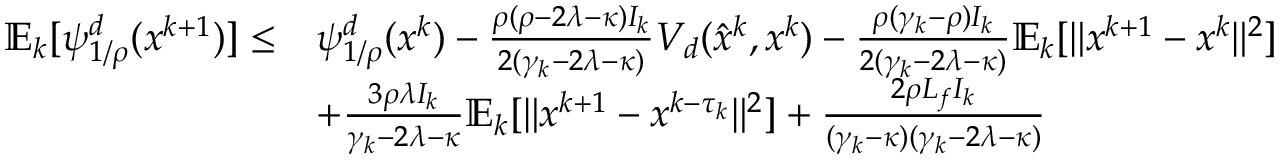Convert formula to latex. <formula><loc_0><loc_0><loc_500><loc_500>\begin{array} { r l } { \mathbb { E } _ { k } [ \psi _ { 1 / \rho } ^ { d } ( x ^ { k + 1 } ) ] \leq } & { \psi _ { 1 / \rho } ^ { d } ( x ^ { k } ) - \frac { \rho ( \rho - 2 \lambda - \kappa ) I _ { k } } { 2 ( \gamma _ { k } - 2 \lambda - \kappa ) } V _ { d } ( \hat { x } ^ { k } , x ^ { k } ) - \frac { \rho ( \gamma _ { k } - \rho ) I _ { k } } { 2 ( \gamma _ { k } - 2 \lambda - \kappa ) } \mathbb { E } _ { k } [ \| x ^ { k + 1 } - x ^ { k } \| ^ { 2 } ] } \\ & { + \frac { 3 \rho \lambda I _ { k } } { \gamma _ { k } - 2 \lambda - \kappa } \mathbb { E } _ { k } [ \| x ^ { k + 1 } - x ^ { k - \tau _ { k } } \| ^ { 2 } ] + \frac { 2 \rho L _ { f } I _ { k } } { ( \gamma _ { k } - \kappa ) ( \gamma _ { k } - 2 \lambda - \kappa ) } } \end{array}</formula> 